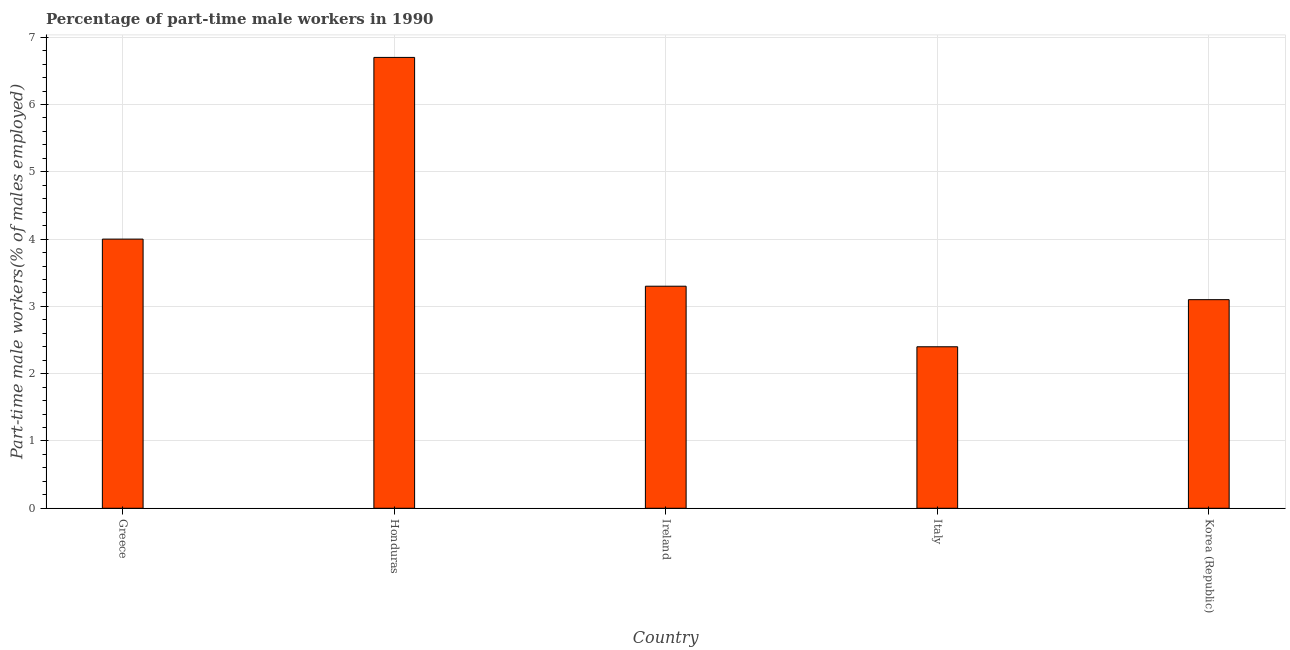Does the graph contain any zero values?
Make the answer very short. No. Does the graph contain grids?
Provide a short and direct response. Yes. What is the title of the graph?
Give a very brief answer. Percentage of part-time male workers in 1990. What is the label or title of the X-axis?
Your response must be concise. Country. What is the label or title of the Y-axis?
Make the answer very short. Part-time male workers(% of males employed). What is the percentage of part-time male workers in Honduras?
Ensure brevity in your answer.  6.7. Across all countries, what is the maximum percentage of part-time male workers?
Give a very brief answer. 6.7. Across all countries, what is the minimum percentage of part-time male workers?
Your response must be concise. 2.4. In which country was the percentage of part-time male workers maximum?
Provide a succinct answer. Honduras. What is the sum of the percentage of part-time male workers?
Your response must be concise. 19.5. What is the difference between the percentage of part-time male workers in Italy and Korea (Republic)?
Provide a succinct answer. -0.7. What is the average percentage of part-time male workers per country?
Keep it short and to the point. 3.9. What is the median percentage of part-time male workers?
Make the answer very short. 3.3. In how many countries, is the percentage of part-time male workers greater than 0.4 %?
Offer a terse response. 5. What is the ratio of the percentage of part-time male workers in Greece to that in Italy?
Your answer should be compact. 1.67. Is the percentage of part-time male workers in Honduras less than that in Italy?
Ensure brevity in your answer.  No. What is the difference between the highest and the second highest percentage of part-time male workers?
Offer a terse response. 2.7. Is the sum of the percentage of part-time male workers in Ireland and Italy greater than the maximum percentage of part-time male workers across all countries?
Make the answer very short. No. How many bars are there?
Keep it short and to the point. 5. What is the Part-time male workers(% of males employed) in Greece?
Provide a short and direct response. 4. What is the Part-time male workers(% of males employed) in Honduras?
Give a very brief answer. 6.7. What is the Part-time male workers(% of males employed) of Ireland?
Your answer should be very brief. 3.3. What is the Part-time male workers(% of males employed) in Italy?
Make the answer very short. 2.4. What is the Part-time male workers(% of males employed) in Korea (Republic)?
Ensure brevity in your answer.  3.1. What is the difference between the Part-time male workers(% of males employed) in Greece and Italy?
Your response must be concise. 1.6. What is the difference between the Part-time male workers(% of males employed) in Greece and Korea (Republic)?
Offer a terse response. 0.9. What is the difference between the Part-time male workers(% of males employed) in Honduras and Ireland?
Your answer should be compact. 3.4. What is the difference between the Part-time male workers(% of males employed) in Honduras and Italy?
Give a very brief answer. 4.3. What is the difference between the Part-time male workers(% of males employed) in Ireland and Italy?
Give a very brief answer. 0.9. What is the difference between the Part-time male workers(% of males employed) in Ireland and Korea (Republic)?
Provide a short and direct response. 0.2. What is the difference between the Part-time male workers(% of males employed) in Italy and Korea (Republic)?
Keep it short and to the point. -0.7. What is the ratio of the Part-time male workers(% of males employed) in Greece to that in Honduras?
Keep it short and to the point. 0.6. What is the ratio of the Part-time male workers(% of males employed) in Greece to that in Ireland?
Provide a short and direct response. 1.21. What is the ratio of the Part-time male workers(% of males employed) in Greece to that in Italy?
Offer a very short reply. 1.67. What is the ratio of the Part-time male workers(% of males employed) in Greece to that in Korea (Republic)?
Ensure brevity in your answer.  1.29. What is the ratio of the Part-time male workers(% of males employed) in Honduras to that in Ireland?
Provide a succinct answer. 2.03. What is the ratio of the Part-time male workers(% of males employed) in Honduras to that in Italy?
Your answer should be compact. 2.79. What is the ratio of the Part-time male workers(% of males employed) in Honduras to that in Korea (Republic)?
Ensure brevity in your answer.  2.16. What is the ratio of the Part-time male workers(% of males employed) in Ireland to that in Italy?
Offer a terse response. 1.38. What is the ratio of the Part-time male workers(% of males employed) in Ireland to that in Korea (Republic)?
Keep it short and to the point. 1.06. What is the ratio of the Part-time male workers(% of males employed) in Italy to that in Korea (Republic)?
Keep it short and to the point. 0.77. 